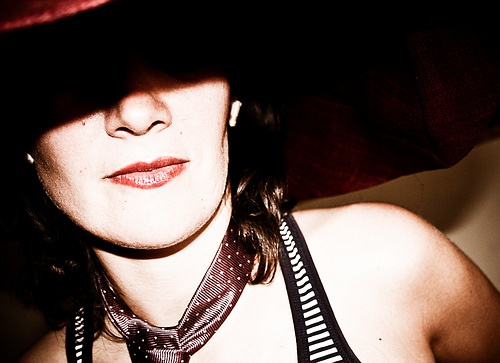Describe the objects in this image and their specific colors. I can see people in black, white, maroon, and tan tones and tie in black, maroon, white, and brown tones in this image. 